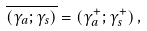Convert formula to latex. <formula><loc_0><loc_0><loc_500><loc_500>\overline { { { ( \gamma _ { a } ; \gamma _ { s } ) } } } = ( \gamma _ { a } ^ { + } ; \gamma _ { s } ^ { + } ) \, ,</formula> 